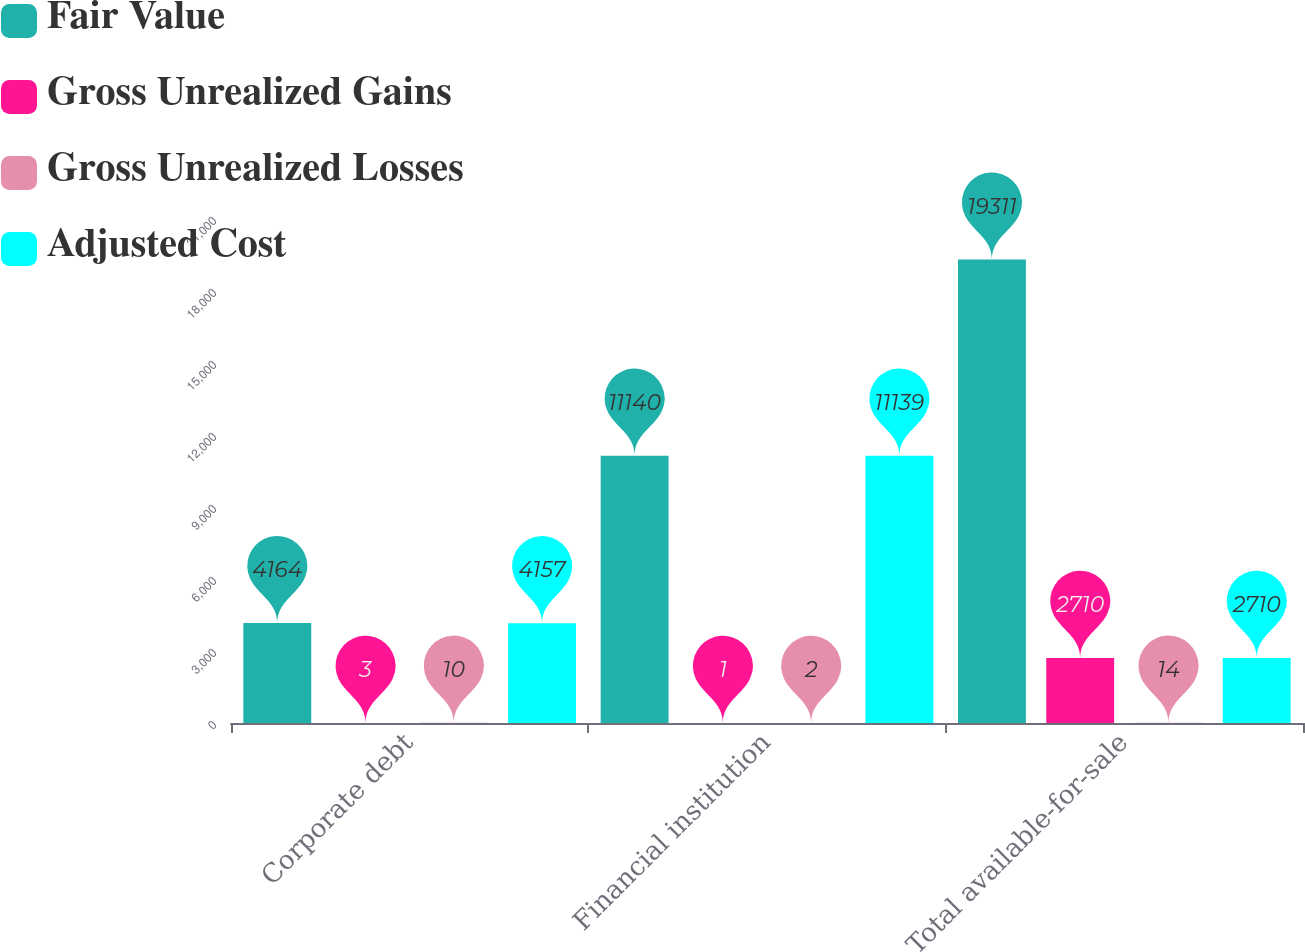<chart> <loc_0><loc_0><loc_500><loc_500><stacked_bar_chart><ecel><fcel>Corporate debt<fcel>Financial institution<fcel>Total available-for-sale<nl><fcel>Fair Value<fcel>4164<fcel>11140<fcel>19311<nl><fcel>Gross Unrealized Gains<fcel>3<fcel>1<fcel>2710<nl><fcel>Gross Unrealized Losses<fcel>10<fcel>2<fcel>14<nl><fcel>Adjusted Cost<fcel>4157<fcel>11139<fcel>2710<nl></chart> 